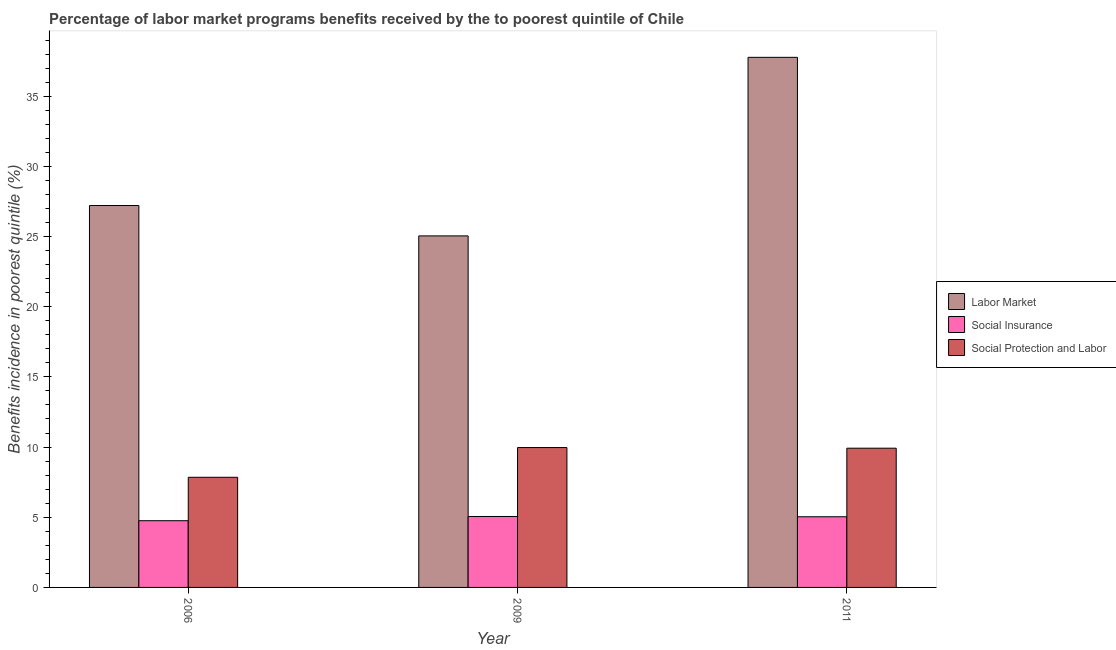How many different coloured bars are there?
Offer a very short reply. 3. How many groups of bars are there?
Keep it short and to the point. 3. Are the number of bars on each tick of the X-axis equal?
Your answer should be very brief. Yes. How many bars are there on the 1st tick from the right?
Provide a short and direct response. 3. What is the label of the 3rd group of bars from the left?
Offer a terse response. 2011. What is the percentage of benefits received due to social insurance programs in 2011?
Your response must be concise. 5.04. Across all years, what is the maximum percentage of benefits received due to social insurance programs?
Provide a succinct answer. 5.05. Across all years, what is the minimum percentage of benefits received due to social protection programs?
Ensure brevity in your answer.  7.85. In which year was the percentage of benefits received due to social insurance programs maximum?
Keep it short and to the point. 2009. In which year was the percentage of benefits received due to labor market programs minimum?
Offer a terse response. 2009. What is the total percentage of benefits received due to social protection programs in the graph?
Provide a short and direct response. 27.73. What is the difference between the percentage of benefits received due to labor market programs in 2009 and that in 2011?
Keep it short and to the point. -12.72. What is the difference between the percentage of benefits received due to social insurance programs in 2006 and the percentage of benefits received due to social protection programs in 2009?
Offer a terse response. -0.3. What is the average percentage of benefits received due to social insurance programs per year?
Keep it short and to the point. 4.95. In how many years, is the percentage of benefits received due to social insurance programs greater than 31 %?
Offer a terse response. 0. What is the ratio of the percentage of benefits received due to social protection programs in 2006 to that in 2009?
Provide a succinct answer. 0.79. Is the percentage of benefits received due to social protection programs in 2009 less than that in 2011?
Offer a terse response. No. Is the difference between the percentage of benefits received due to social insurance programs in 2006 and 2011 greater than the difference between the percentage of benefits received due to labor market programs in 2006 and 2011?
Keep it short and to the point. No. What is the difference between the highest and the second highest percentage of benefits received due to social insurance programs?
Your answer should be very brief. 0.02. What is the difference between the highest and the lowest percentage of benefits received due to social insurance programs?
Your answer should be compact. 0.3. In how many years, is the percentage of benefits received due to social protection programs greater than the average percentage of benefits received due to social protection programs taken over all years?
Offer a terse response. 2. What does the 2nd bar from the left in 2011 represents?
Give a very brief answer. Social Insurance. What does the 2nd bar from the right in 2006 represents?
Your answer should be very brief. Social Insurance. Is it the case that in every year, the sum of the percentage of benefits received due to labor market programs and percentage of benefits received due to social insurance programs is greater than the percentage of benefits received due to social protection programs?
Offer a very short reply. Yes. How many bars are there?
Provide a succinct answer. 9. Are the values on the major ticks of Y-axis written in scientific E-notation?
Give a very brief answer. No. Does the graph contain any zero values?
Provide a short and direct response. No. Does the graph contain grids?
Your answer should be compact. No. Where does the legend appear in the graph?
Provide a succinct answer. Center right. How many legend labels are there?
Provide a short and direct response. 3. What is the title of the graph?
Your answer should be very brief. Percentage of labor market programs benefits received by the to poorest quintile of Chile. What is the label or title of the X-axis?
Offer a very short reply. Year. What is the label or title of the Y-axis?
Make the answer very short. Benefits incidence in poorest quintile (%). What is the Benefits incidence in poorest quintile (%) in Labor Market in 2006?
Keep it short and to the point. 27.21. What is the Benefits incidence in poorest quintile (%) in Social Insurance in 2006?
Your response must be concise. 4.75. What is the Benefits incidence in poorest quintile (%) in Social Protection and Labor in 2006?
Offer a very short reply. 7.85. What is the Benefits incidence in poorest quintile (%) in Labor Market in 2009?
Keep it short and to the point. 25.05. What is the Benefits incidence in poorest quintile (%) of Social Insurance in 2009?
Ensure brevity in your answer.  5.05. What is the Benefits incidence in poorest quintile (%) in Social Protection and Labor in 2009?
Give a very brief answer. 9.97. What is the Benefits incidence in poorest quintile (%) of Labor Market in 2011?
Provide a short and direct response. 37.77. What is the Benefits incidence in poorest quintile (%) in Social Insurance in 2011?
Provide a short and direct response. 5.04. What is the Benefits incidence in poorest quintile (%) in Social Protection and Labor in 2011?
Keep it short and to the point. 9.92. Across all years, what is the maximum Benefits incidence in poorest quintile (%) of Labor Market?
Make the answer very short. 37.77. Across all years, what is the maximum Benefits incidence in poorest quintile (%) in Social Insurance?
Your answer should be very brief. 5.05. Across all years, what is the maximum Benefits incidence in poorest quintile (%) of Social Protection and Labor?
Offer a terse response. 9.97. Across all years, what is the minimum Benefits incidence in poorest quintile (%) in Labor Market?
Offer a very short reply. 25.05. Across all years, what is the minimum Benefits incidence in poorest quintile (%) of Social Insurance?
Provide a short and direct response. 4.75. Across all years, what is the minimum Benefits incidence in poorest quintile (%) of Social Protection and Labor?
Make the answer very short. 7.85. What is the total Benefits incidence in poorest quintile (%) of Labor Market in the graph?
Provide a short and direct response. 90.02. What is the total Benefits incidence in poorest quintile (%) in Social Insurance in the graph?
Ensure brevity in your answer.  14.84. What is the total Benefits incidence in poorest quintile (%) in Social Protection and Labor in the graph?
Make the answer very short. 27.73. What is the difference between the Benefits incidence in poorest quintile (%) of Labor Market in 2006 and that in 2009?
Your answer should be compact. 2.16. What is the difference between the Benefits incidence in poorest quintile (%) in Social Insurance in 2006 and that in 2009?
Make the answer very short. -0.3. What is the difference between the Benefits incidence in poorest quintile (%) in Social Protection and Labor in 2006 and that in 2009?
Give a very brief answer. -2.12. What is the difference between the Benefits incidence in poorest quintile (%) in Labor Market in 2006 and that in 2011?
Your answer should be compact. -10.56. What is the difference between the Benefits incidence in poorest quintile (%) in Social Insurance in 2006 and that in 2011?
Offer a terse response. -0.28. What is the difference between the Benefits incidence in poorest quintile (%) of Social Protection and Labor in 2006 and that in 2011?
Offer a very short reply. -2.07. What is the difference between the Benefits incidence in poorest quintile (%) in Labor Market in 2009 and that in 2011?
Provide a succinct answer. -12.72. What is the difference between the Benefits incidence in poorest quintile (%) in Social Insurance in 2009 and that in 2011?
Offer a terse response. 0.02. What is the difference between the Benefits incidence in poorest quintile (%) in Social Protection and Labor in 2009 and that in 2011?
Your answer should be very brief. 0.05. What is the difference between the Benefits incidence in poorest quintile (%) in Labor Market in 2006 and the Benefits incidence in poorest quintile (%) in Social Insurance in 2009?
Your response must be concise. 22.16. What is the difference between the Benefits incidence in poorest quintile (%) in Labor Market in 2006 and the Benefits incidence in poorest quintile (%) in Social Protection and Labor in 2009?
Offer a very short reply. 17.24. What is the difference between the Benefits incidence in poorest quintile (%) in Social Insurance in 2006 and the Benefits incidence in poorest quintile (%) in Social Protection and Labor in 2009?
Offer a terse response. -5.21. What is the difference between the Benefits incidence in poorest quintile (%) of Labor Market in 2006 and the Benefits incidence in poorest quintile (%) of Social Insurance in 2011?
Ensure brevity in your answer.  22.17. What is the difference between the Benefits incidence in poorest quintile (%) in Labor Market in 2006 and the Benefits incidence in poorest quintile (%) in Social Protection and Labor in 2011?
Provide a short and direct response. 17.29. What is the difference between the Benefits incidence in poorest quintile (%) of Social Insurance in 2006 and the Benefits incidence in poorest quintile (%) of Social Protection and Labor in 2011?
Offer a very short reply. -5.17. What is the difference between the Benefits incidence in poorest quintile (%) of Labor Market in 2009 and the Benefits incidence in poorest quintile (%) of Social Insurance in 2011?
Offer a very short reply. 20.01. What is the difference between the Benefits incidence in poorest quintile (%) of Labor Market in 2009 and the Benefits incidence in poorest quintile (%) of Social Protection and Labor in 2011?
Your answer should be compact. 15.13. What is the difference between the Benefits incidence in poorest quintile (%) in Social Insurance in 2009 and the Benefits incidence in poorest quintile (%) in Social Protection and Labor in 2011?
Your response must be concise. -4.87. What is the average Benefits incidence in poorest quintile (%) in Labor Market per year?
Your answer should be compact. 30.01. What is the average Benefits incidence in poorest quintile (%) of Social Insurance per year?
Provide a succinct answer. 4.95. What is the average Benefits incidence in poorest quintile (%) of Social Protection and Labor per year?
Make the answer very short. 9.24. In the year 2006, what is the difference between the Benefits incidence in poorest quintile (%) in Labor Market and Benefits incidence in poorest quintile (%) in Social Insurance?
Your answer should be very brief. 22.46. In the year 2006, what is the difference between the Benefits incidence in poorest quintile (%) in Labor Market and Benefits incidence in poorest quintile (%) in Social Protection and Labor?
Offer a very short reply. 19.36. In the year 2006, what is the difference between the Benefits incidence in poorest quintile (%) in Social Insurance and Benefits incidence in poorest quintile (%) in Social Protection and Labor?
Your response must be concise. -3.09. In the year 2009, what is the difference between the Benefits incidence in poorest quintile (%) of Labor Market and Benefits incidence in poorest quintile (%) of Social Insurance?
Give a very brief answer. 19.99. In the year 2009, what is the difference between the Benefits incidence in poorest quintile (%) in Labor Market and Benefits incidence in poorest quintile (%) in Social Protection and Labor?
Make the answer very short. 15.08. In the year 2009, what is the difference between the Benefits incidence in poorest quintile (%) of Social Insurance and Benefits incidence in poorest quintile (%) of Social Protection and Labor?
Provide a short and direct response. -4.91. In the year 2011, what is the difference between the Benefits incidence in poorest quintile (%) in Labor Market and Benefits incidence in poorest quintile (%) in Social Insurance?
Provide a succinct answer. 32.73. In the year 2011, what is the difference between the Benefits incidence in poorest quintile (%) of Labor Market and Benefits incidence in poorest quintile (%) of Social Protection and Labor?
Your answer should be very brief. 27.85. In the year 2011, what is the difference between the Benefits incidence in poorest quintile (%) in Social Insurance and Benefits incidence in poorest quintile (%) in Social Protection and Labor?
Offer a terse response. -4.88. What is the ratio of the Benefits incidence in poorest quintile (%) of Labor Market in 2006 to that in 2009?
Your response must be concise. 1.09. What is the ratio of the Benefits incidence in poorest quintile (%) in Social Insurance in 2006 to that in 2009?
Make the answer very short. 0.94. What is the ratio of the Benefits incidence in poorest quintile (%) of Social Protection and Labor in 2006 to that in 2009?
Provide a succinct answer. 0.79. What is the ratio of the Benefits incidence in poorest quintile (%) of Labor Market in 2006 to that in 2011?
Offer a very short reply. 0.72. What is the ratio of the Benefits incidence in poorest quintile (%) of Social Insurance in 2006 to that in 2011?
Your answer should be compact. 0.94. What is the ratio of the Benefits incidence in poorest quintile (%) of Social Protection and Labor in 2006 to that in 2011?
Provide a short and direct response. 0.79. What is the ratio of the Benefits incidence in poorest quintile (%) of Labor Market in 2009 to that in 2011?
Ensure brevity in your answer.  0.66. What is the ratio of the Benefits incidence in poorest quintile (%) of Social Protection and Labor in 2009 to that in 2011?
Provide a succinct answer. 1. What is the difference between the highest and the second highest Benefits incidence in poorest quintile (%) of Labor Market?
Provide a short and direct response. 10.56. What is the difference between the highest and the second highest Benefits incidence in poorest quintile (%) of Social Insurance?
Offer a very short reply. 0.02. What is the difference between the highest and the second highest Benefits incidence in poorest quintile (%) in Social Protection and Labor?
Your answer should be compact. 0.05. What is the difference between the highest and the lowest Benefits incidence in poorest quintile (%) in Labor Market?
Provide a short and direct response. 12.72. What is the difference between the highest and the lowest Benefits incidence in poorest quintile (%) of Social Insurance?
Keep it short and to the point. 0.3. What is the difference between the highest and the lowest Benefits incidence in poorest quintile (%) of Social Protection and Labor?
Ensure brevity in your answer.  2.12. 